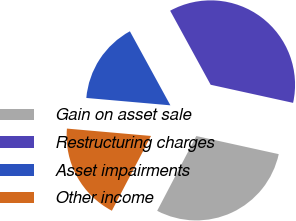<chart> <loc_0><loc_0><loc_500><loc_500><pie_chart><fcel>Gain on asset sale<fcel>Restructuring charges<fcel>Asset impairments<fcel>Other income<nl><fcel>29.23%<fcel>36.41%<fcel>15.64%<fcel>18.72%<nl></chart> 